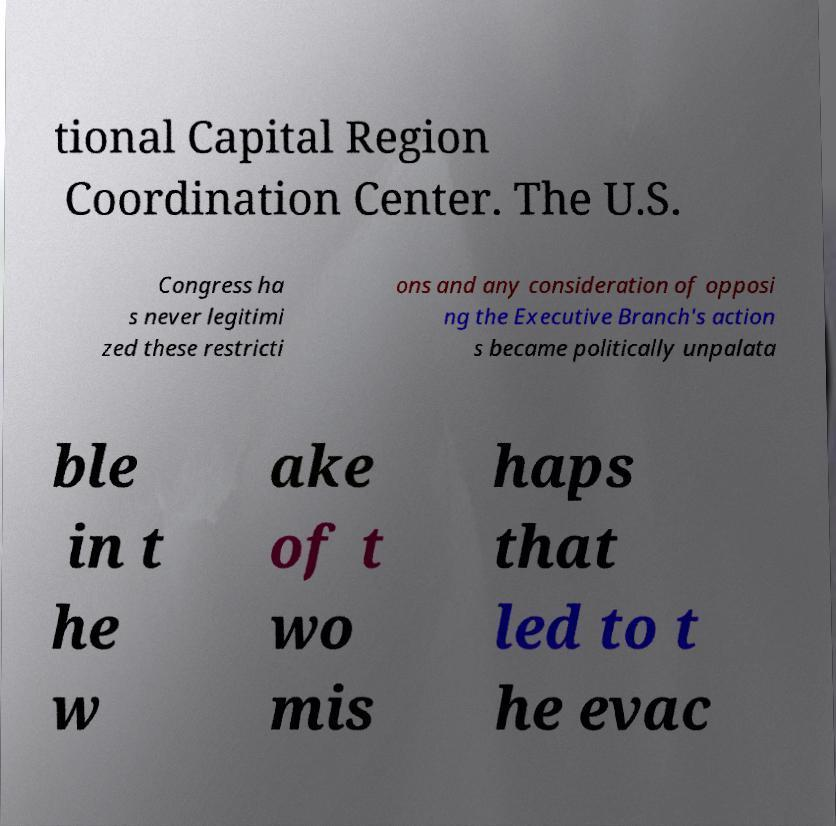Could you extract and type out the text from this image? tional Capital Region Coordination Center. The U.S. Congress ha s never legitimi zed these restricti ons and any consideration of opposi ng the Executive Branch's action s became politically unpalata ble in t he w ake of t wo mis haps that led to t he evac 